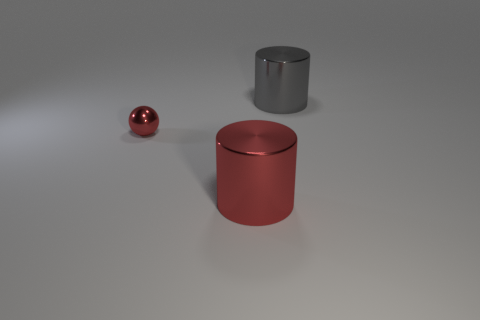Are there any other things that have the same size as the ball?
Provide a short and direct response. No. Is there a gray shiny object that has the same size as the red shiny sphere?
Make the answer very short. No. How many metal objects are large things or gray objects?
Offer a terse response. 2. The small red thing that is the same material as the gray cylinder is what shape?
Provide a succinct answer. Sphere. What number of things are both to the right of the tiny ball and left of the gray object?
Keep it short and to the point. 1. Are there any other things that are the same shape as the tiny red object?
Your answer should be compact. No. What size is the metallic cylinder that is in front of the red metallic ball?
Your response must be concise. Large. What material is the large thing in front of the metallic object that is behind the small sphere?
Your answer should be compact. Metal. Does the big cylinder right of the big red metal object have the same color as the tiny object?
Offer a very short reply. No. Is there anything else that is made of the same material as the small red sphere?
Give a very brief answer. Yes. 